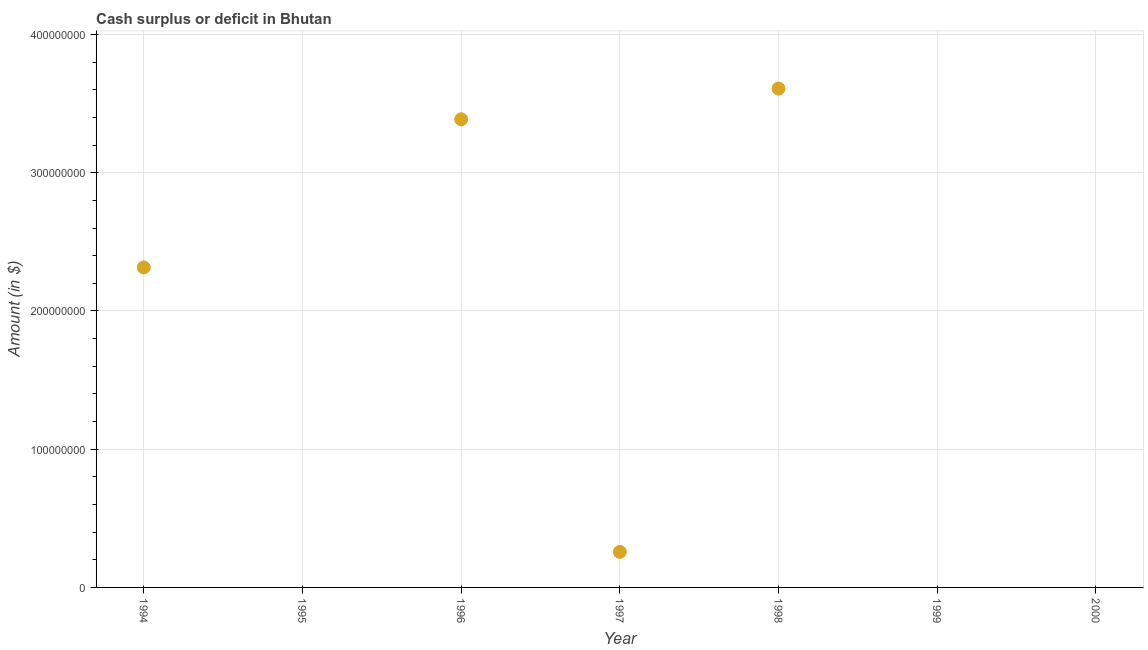Across all years, what is the maximum cash surplus or deficit?
Your response must be concise. 3.61e+08. Across all years, what is the minimum cash surplus or deficit?
Your response must be concise. 0. What is the sum of the cash surplus or deficit?
Offer a very short reply. 9.57e+08. What is the difference between the cash surplus or deficit in 1994 and 1998?
Make the answer very short. -1.29e+08. What is the average cash surplus or deficit per year?
Ensure brevity in your answer.  1.37e+08. What is the median cash surplus or deficit?
Make the answer very short. 2.57e+07. In how many years, is the cash surplus or deficit greater than 280000000 $?
Your answer should be compact. 2. What is the ratio of the cash surplus or deficit in 1994 to that in 1996?
Give a very brief answer. 0.68. Is the cash surplus or deficit in 1994 less than that in 1997?
Make the answer very short. No. What is the difference between the highest and the second highest cash surplus or deficit?
Your answer should be very brief. 2.22e+07. Is the sum of the cash surplus or deficit in 1996 and 1997 greater than the maximum cash surplus or deficit across all years?
Your answer should be compact. Yes. What is the difference between the highest and the lowest cash surplus or deficit?
Offer a very short reply. 3.61e+08. Does the cash surplus or deficit monotonically increase over the years?
Your answer should be very brief. No. How many dotlines are there?
Your answer should be very brief. 1. How many years are there in the graph?
Your response must be concise. 7. Does the graph contain any zero values?
Your answer should be very brief. Yes. What is the title of the graph?
Provide a succinct answer. Cash surplus or deficit in Bhutan. What is the label or title of the X-axis?
Your answer should be very brief. Year. What is the label or title of the Y-axis?
Your answer should be compact. Amount (in $). What is the Amount (in $) in 1994?
Keep it short and to the point. 2.32e+08. What is the Amount (in $) in 1995?
Your response must be concise. 0. What is the Amount (in $) in 1996?
Ensure brevity in your answer.  3.39e+08. What is the Amount (in $) in 1997?
Your answer should be compact. 2.57e+07. What is the Amount (in $) in 1998?
Make the answer very short. 3.61e+08. What is the Amount (in $) in 2000?
Give a very brief answer. 0. What is the difference between the Amount (in $) in 1994 and 1996?
Your answer should be very brief. -1.07e+08. What is the difference between the Amount (in $) in 1994 and 1997?
Keep it short and to the point. 2.06e+08. What is the difference between the Amount (in $) in 1994 and 1998?
Ensure brevity in your answer.  -1.29e+08. What is the difference between the Amount (in $) in 1996 and 1997?
Make the answer very short. 3.13e+08. What is the difference between the Amount (in $) in 1996 and 1998?
Provide a short and direct response. -2.22e+07. What is the difference between the Amount (in $) in 1997 and 1998?
Your response must be concise. -3.35e+08. What is the ratio of the Amount (in $) in 1994 to that in 1996?
Ensure brevity in your answer.  0.68. What is the ratio of the Amount (in $) in 1994 to that in 1997?
Your answer should be compact. 9.01. What is the ratio of the Amount (in $) in 1994 to that in 1998?
Your response must be concise. 0.64. What is the ratio of the Amount (in $) in 1996 to that in 1997?
Offer a very short reply. 13.18. What is the ratio of the Amount (in $) in 1996 to that in 1998?
Your answer should be compact. 0.94. What is the ratio of the Amount (in $) in 1997 to that in 1998?
Ensure brevity in your answer.  0.07. 